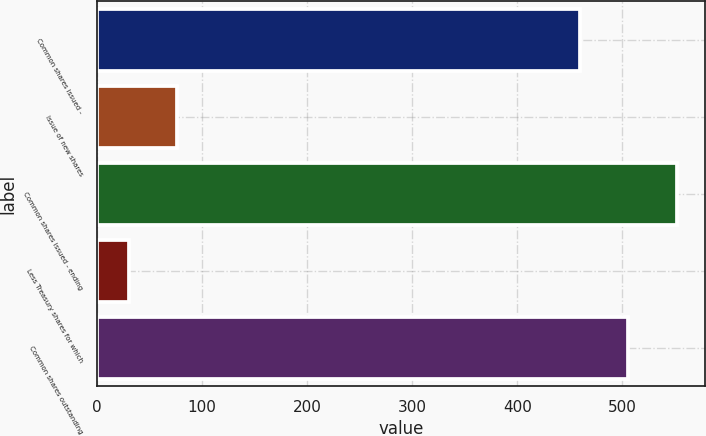Convert chart. <chart><loc_0><loc_0><loc_500><loc_500><bar_chart><fcel>Common shares issued -<fcel>Issue of new shares<fcel>Common shares issued - ending<fcel>Less Treasury shares for which<fcel>Common shares outstanding<nl><fcel>459.5<fcel>76.31<fcel>551.52<fcel>30.3<fcel>505.51<nl></chart> 